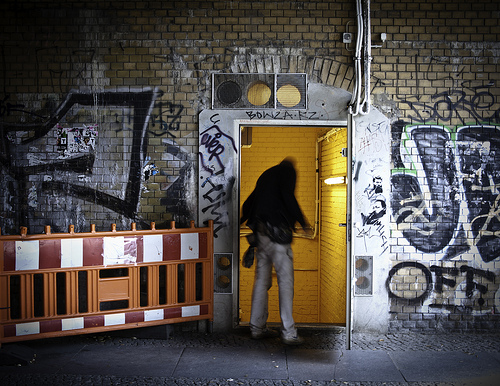Please provide a short description for this region: [0.02, 0.59, 0.42, 0.64]. This region shows a red and white checkered strip, serving as a cautionary barrier along a street with vibrant urban art, framing the chaotic beauty of street murals. 